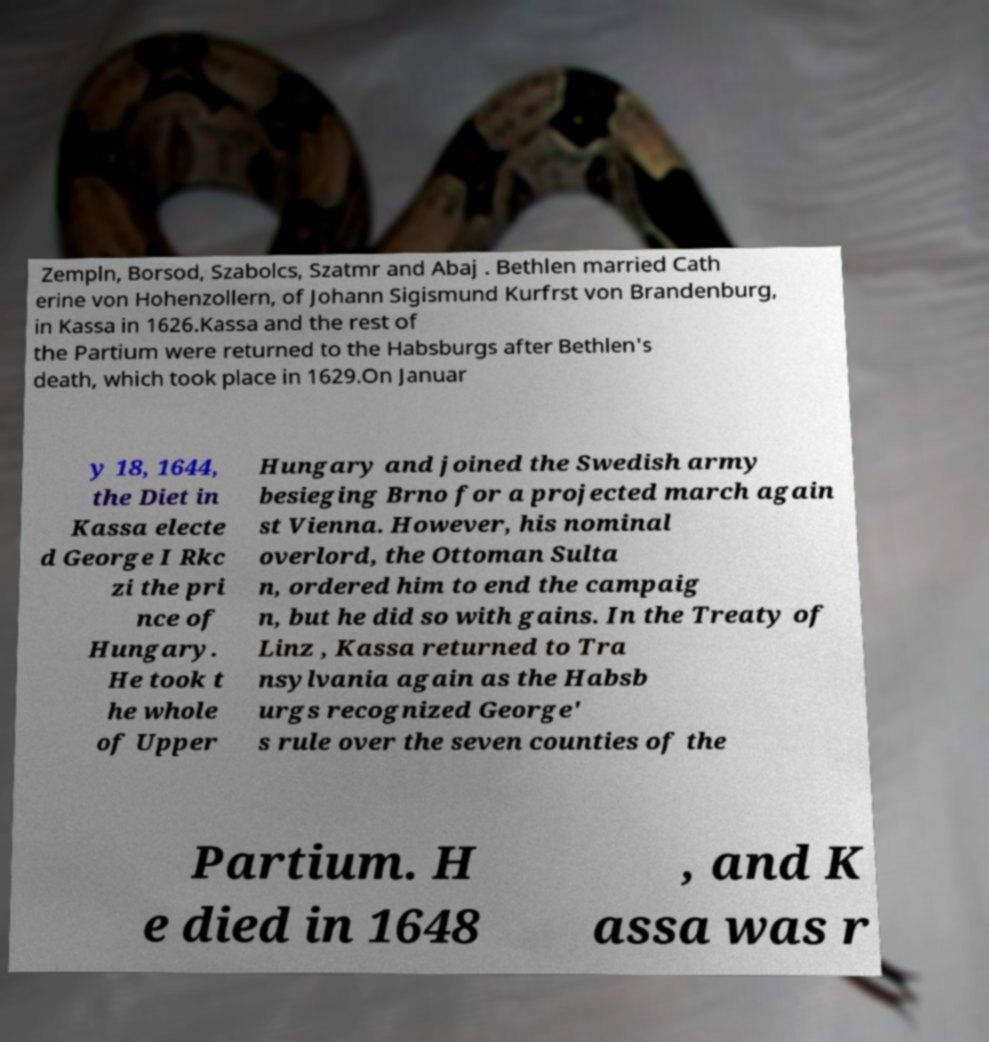Please identify and transcribe the text found in this image. Zempln, Borsod, Szabolcs, Szatmr and Abaj . Bethlen married Cath erine von Hohenzollern, of Johann Sigismund Kurfrst von Brandenburg, in Kassa in 1626.Kassa and the rest of the Partium were returned to the Habsburgs after Bethlen's death, which took place in 1629.On Januar y 18, 1644, the Diet in Kassa electe d George I Rkc zi the pri nce of Hungary. He took t he whole of Upper Hungary and joined the Swedish army besieging Brno for a projected march again st Vienna. However, his nominal overlord, the Ottoman Sulta n, ordered him to end the campaig n, but he did so with gains. In the Treaty of Linz , Kassa returned to Tra nsylvania again as the Habsb urgs recognized George' s rule over the seven counties of the Partium. H e died in 1648 , and K assa was r 